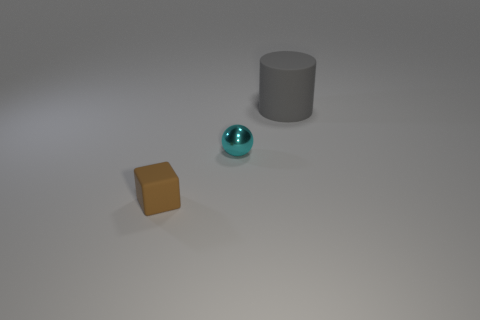Are there any other things that have the same size as the gray matte thing?
Your answer should be compact. No. Is there anything else that is made of the same material as the tiny cyan thing?
Your answer should be compact. No. Does the tiny rubber thing have the same shape as the metal thing?
Give a very brief answer. No. There is a object in front of the metal ball; is its shape the same as the small metal thing?
Offer a terse response. No. There is a tiny thing to the right of the brown matte object; what is its material?
Ensure brevity in your answer.  Metal. Is there a big gray cylinder that has the same material as the brown thing?
Offer a very short reply. Yes. The gray matte cylinder has what size?
Provide a succinct answer. Large. What number of brown objects are blocks or shiny spheres?
Your answer should be compact. 1. What number of other green matte spheres are the same size as the sphere?
Give a very brief answer. 0. What color is the thing in front of the metal object?
Offer a very short reply. Brown. 